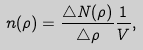<formula> <loc_0><loc_0><loc_500><loc_500>n ( \rho ) = \frac { \triangle N ( \rho ) } { \triangle \rho } \frac { 1 } { V } ,</formula> 